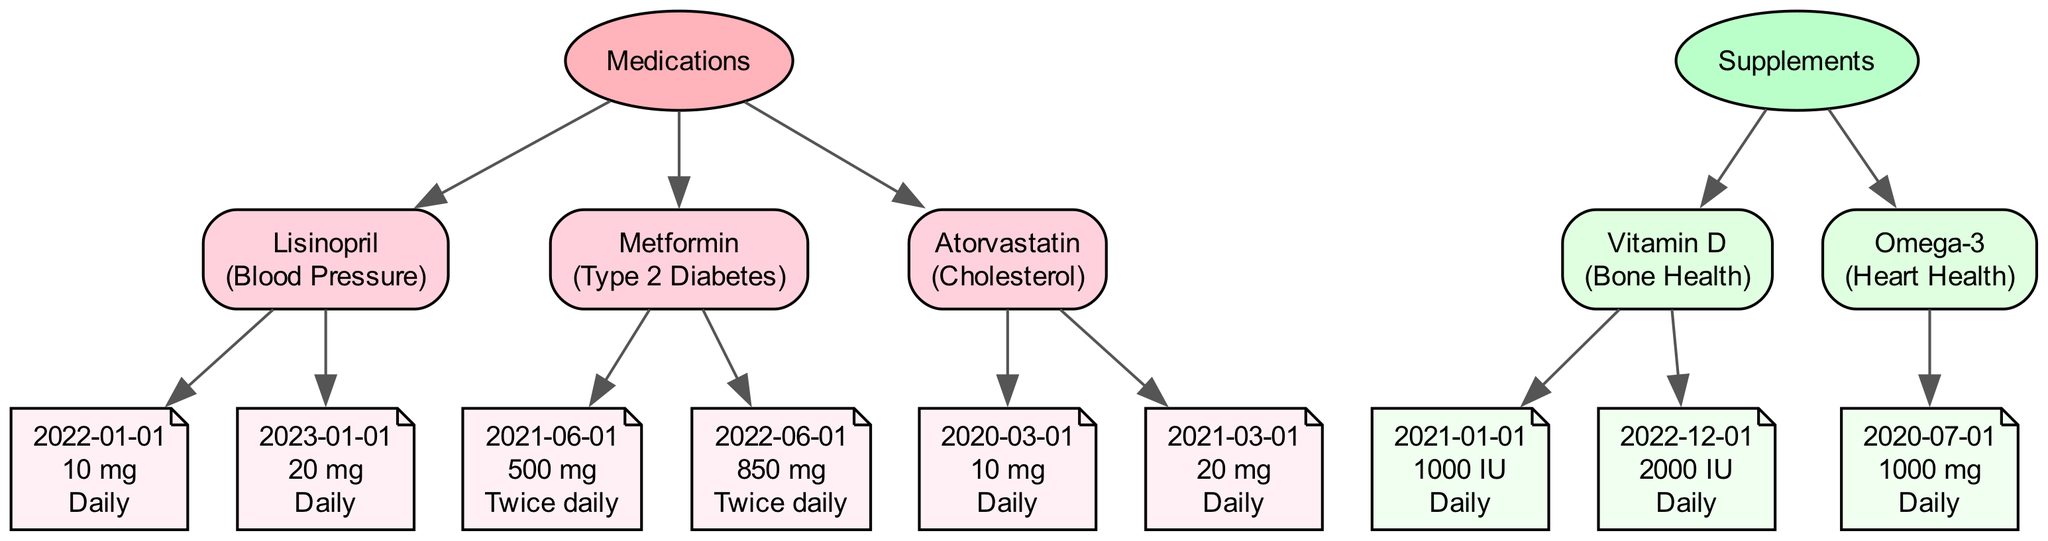What is the purpose of Lisinopril? Lisinopril is listed in the diagram with the purpose indicated next to its name. It is used for "Blood Pressure," as per the node information.
Answer: Blood Pressure How many dosages are recorded for Metformin? The diagram includes two dosage entries for Metformin, each dated and providing dose information. By counting the number of dosage nodes connected to Metformin, we find there are two didactic entries.
Answer: 2 What was the dosage of Atorvastatin on March 1, 2021? Referring to the Atorvastatin node in the diagram, the specific dosage is listed under its respective dosage nodes. The date March 1, 2021 shows "20 mg" as the dosage.
Answer: 20 mg Which supplement is intended for Heart Health? The diagram allows for a quick lookup of supplements and their purposes. Connecting the "Supplements" node to the relevant supplement, Omega-3 is paired with the purpose "Heart Health."
Answer: Omega-3 What dose of Vitamin D was taken on December 1, 2022? The dosage details are shown in the node beneath Vitamin D, and December 1, 2022 specifies "2000 IU" as the dosage.
Answer: 2000 IU What medication’s dosage increased from 10 mg to 20 mg? By examining the dosage history for each medication, it is noted that Lisinopril's dosage changed from 10 mg to 20 mg over time, showing an increase.
Answer: Lisinopril Which medication has the earliest start date in the diagram? By reviewing the date information within each medication node, Atorvastatin starts as early as March 1, 2020, making it the earliest recorded medication in the diagram.
Answer: Atorvastatin How often was Omega-3 dosed? The frequency is illustrated next to Omega-3's dosage detail. The diagram shows it was taken "Daily," easy to identify under the Omega-3 dosage node.
Answer: Daily What is the highest dosage recorded for Metformin? Reviewing the dosage records for Metformin, the maximum value found is "850 mg," as indicated in the node for that medication's later dosage entry.
Answer: 850 mg 